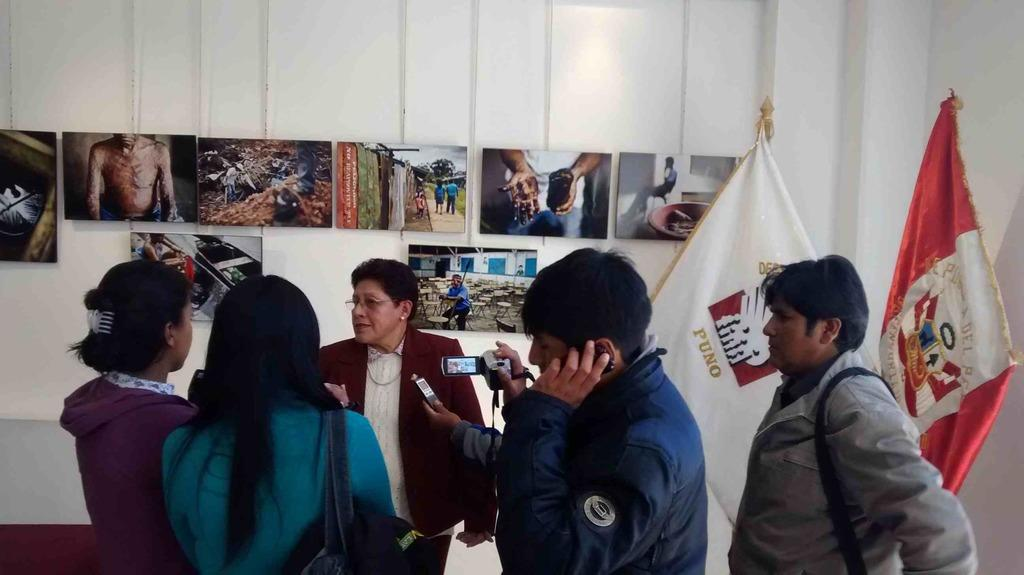What is the color of the wall in the image? The wall in the image is white. What else can be seen in the image besides the wall? There is a group of people, flags, photos, a camera, and a mobile phone in the image. What might the people in the image be doing? The presence of a camera and mobile phone suggests that the group of people might be taking photos or recording a video. What can be used to capture images in the image? There is a camera in the image that can be used to capture images. Can you see a gun in the image? No, there is no gun present in the image. Who is the father of the person holding the machine in the image? There is no machine or person holding a machine in the image. 